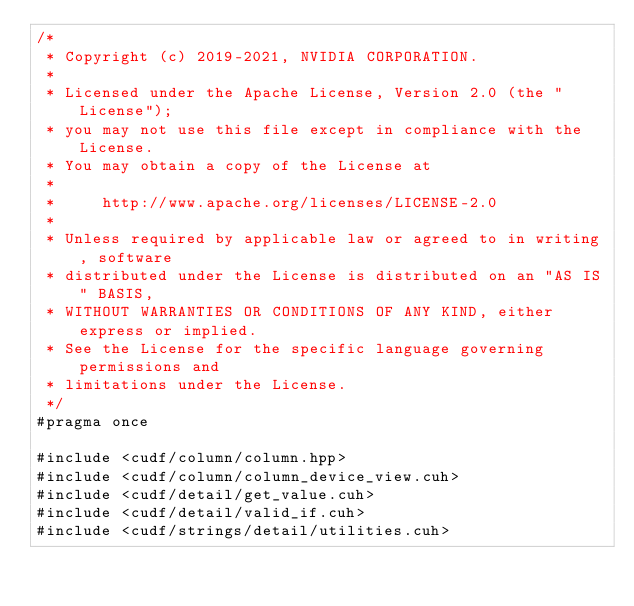Convert code to text. <code><loc_0><loc_0><loc_500><loc_500><_Cuda_>/*
 * Copyright (c) 2019-2021, NVIDIA CORPORATION.
 *
 * Licensed under the Apache License, Version 2.0 (the "License");
 * you may not use this file except in compliance with the License.
 * You may obtain a copy of the License at
 *
 *     http://www.apache.org/licenses/LICENSE-2.0
 *
 * Unless required by applicable law or agreed to in writing, software
 * distributed under the License is distributed on an "AS IS" BASIS,
 * WITHOUT WARRANTIES OR CONDITIONS OF ANY KIND, either express or implied.
 * See the License for the specific language governing permissions and
 * limitations under the License.
 */
#pragma once

#include <cudf/column/column.hpp>
#include <cudf/column/column_device_view.cuh>
#include <cudf/detail/get_value.cuh>
#include <cudf/detail/valid_if.cuh>
#include <cudf/strings/detail/utilities.cuh></code> 